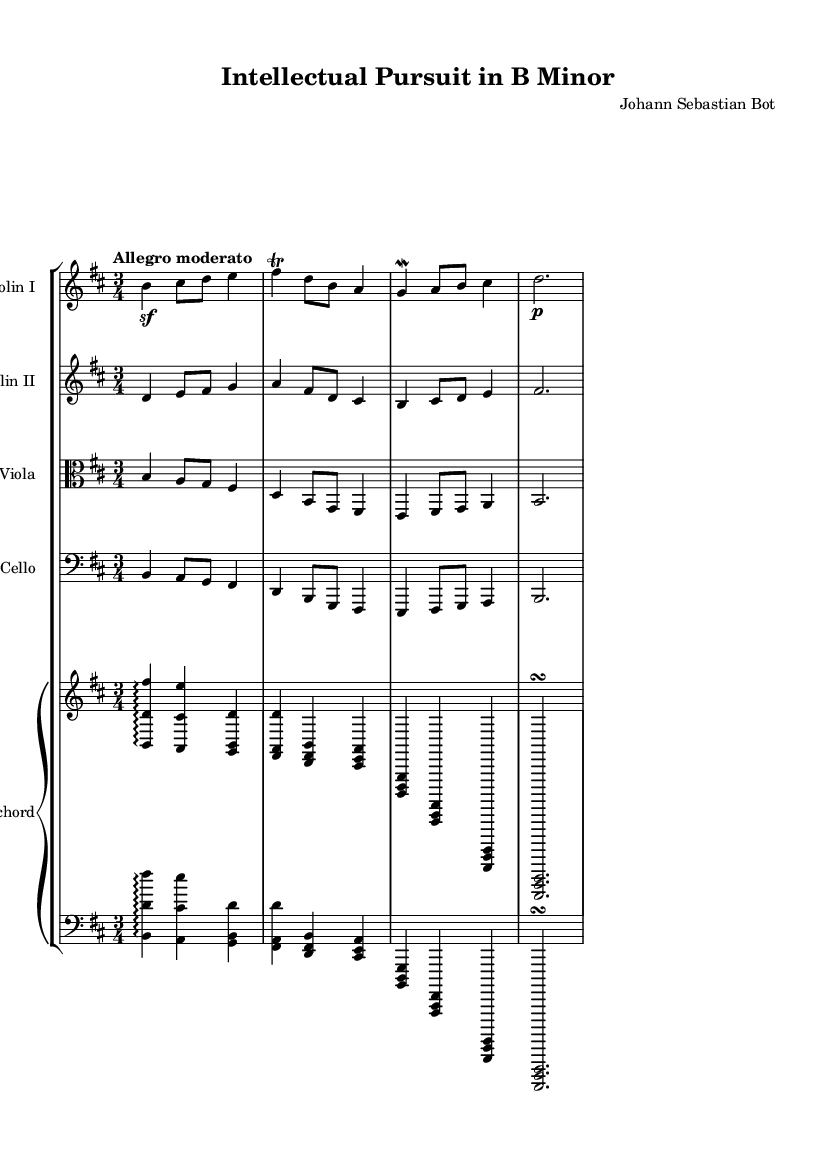What is the key signature of this music? The key signature is indicated at the beginning of the staff, showing two sharps, which means the piece is in B minor.
Answer: B minor What is the time signature of this music? The time signature is shown at the beginning of the score, where it indicates a 3/4 meter, meaning there are three beats per measure.
Answer: 3/4 What is the tempo marking of this music? The tempo marking is written above the staff, indicating "Allegro moderato," which suggests a moderately fast pace.
Answer: Allegro moderato How many instruments are in this chamber music piece? By counting the individual staves in the score, we can see there are five staves: two violins, one viola, one cello, and one harpsichord.
Answer: Five What type of ornamentation is included in the violin part? In the violin part, a trill and a mordent are visible, which are common ornaments in Baroque music, adding expressiveness to the melody.
Answer: Trill and mordent What is the texture of the music based on the number of parts? The score features multiple independent lines, suggesting a polyphonic texture typical of Baroque chamber music, where melodies intertwine seamlessly.
Answer: Polyphonic What is the harmonic role of the harpsichord in this music? The harpsichord provides harmonic support and plays arpeggiated chords, serving as the continuo, which is characteristic of Baroque ensemble music.
Answer: Continuo 